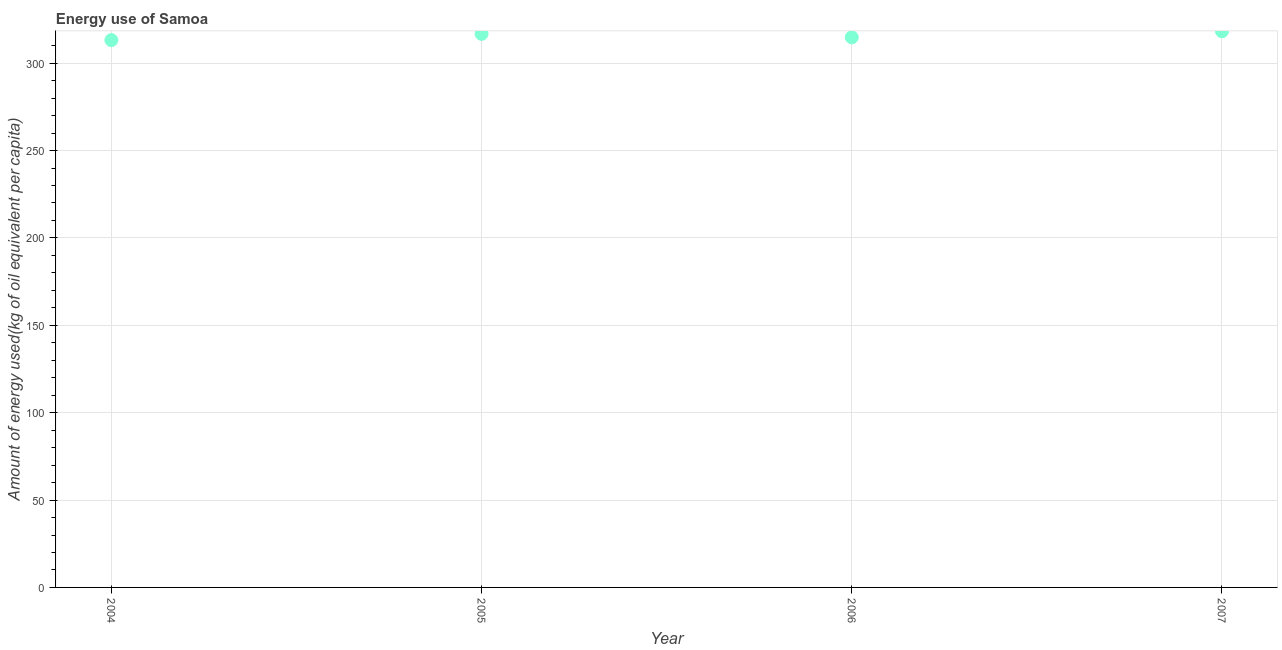What is the amount of energy used in 2004?
Keep it short and to the point. 313.21. Across all years, what is the maximum amount of energy used?
Your answer should be compact. 318.27. Across all years, what is the minimum amount of energy used?
Your response must be concise. 313.21. In which year was the amount of energy used maximum?
Your answer should be very brief. 2007. In which year was the amount of energy used minimum?
Offer a terse response. 2004. What is the sum of the amount of energy used?
Ensure brevity in your answer.  1263.06. What is the difference between the amount of energy used in 2004 and 2005?
Ensure brevity in your answer.  -3.58. What is the average amount of energy used per year?
Offer a very short reply. 315.77. What is the median amount of energy used?
Your response must be concise. 315.79. Do a majority of the years between 2005 and 2007 (inclusive) have amount of energy used greater than 50 kg?
Give a very brief answer. Yes. What is the ratio of the amount of energy used in 2006 to that in 2007?
Give a very brief answer. 0.99. Is the difference between the amount of energy used in 2005 and 2006 greater than the difference between any two years?
Provide a short and direct response. No. What is the difference between the highest and the second highest amount of energy used?
Provide a succinct answer. 1.47. Is the sum of the amount of energy used in 2005 and 2006 greater than the maximum amount of energy used across all years?
Provide a short and direct response. Yes. What is the difference between the highest and the lowest amount of energy used?
Your response must be concise. 5.06. Does the amount of energy used monotonically increase over the years?
Your answer should be very brief. No. How many dotlines are there?
Make the answer very short. 1. How many years are there in the graph?
Make the answer very short. 4. What is the difference between two consecutive major ticks on the Y-axis?
Provide a short and direct response. 50. Are the values on the major ticks of Y-axis written in scientific E-notation?
Offer a very short reply. No. Does the graph contain grids?
Offer a very short reply. Yes. What is the title of the graph?
Keep it short and to the point. Energy use of Samoa. What is the label or title of the X-axis?
Your answer should be compact. Year. What is the label or title of the Y-axis?
Offer a terse response. Amount of energy used(kg of oil equivalent per capita). What is the Amount of energy used(kg of oil equivalent per capita) in 2004?
Make the answer very short. 313.21. What is the Amount of energy used(kg of oil equivalent per capita) in 2005?
Make the answer very short. 316.79. What is the Amount of energy used(kg of oil equivalent per capita) in 2006?
Provide a short and direct response. 314.79. What is the Amount of energy used(kg of oil equivalent per capita) in 2007?
Make the answer very short. 318.27. What is the difference between the Amount of energy used(kg of oil equivalent per capita) in 2004 and 2005?
Offer a very short reply. -3.58. What is the difference between the Amount of energy used(kg of oil equivalent per capita) in 2004 and 2006?
Your answer should be compact. -1.58. What is the difference between the Amount of energy used(kg of oil equivalent per capita) in 2004 and 2007?
Your response must be concise. -5.06. What is the difference between the Amount of energy used(kg of oil equivalent per capita) in 2005 and 2006?
Keep it short and to the point. 2. What is the difference between the Amount of energy used(kg of oil equivalent per capita) in 2005 and 2007?
Make the answer very short. -1.47. What is the difference between the Amount of energy used(kg of oil equivalent per capita) in 2006 and 2007?
Provide a short and direct response. -3.47. What is the ratio of the Amount of energy used(kg of oil equivalent per capita) in 2004 to that in 2006?
Make the answer very short. 0.99. What is the ratio of the Amount of energy used(kg of oil equivalent per capita) in 2005 to that in 2007?
Your response must be concise. 0.99. What is the ratio of the Amount of energy used(kg of oil equivalent per capita) in 2006 to that in 2007?
Provide a short and direct response. 0.99. 